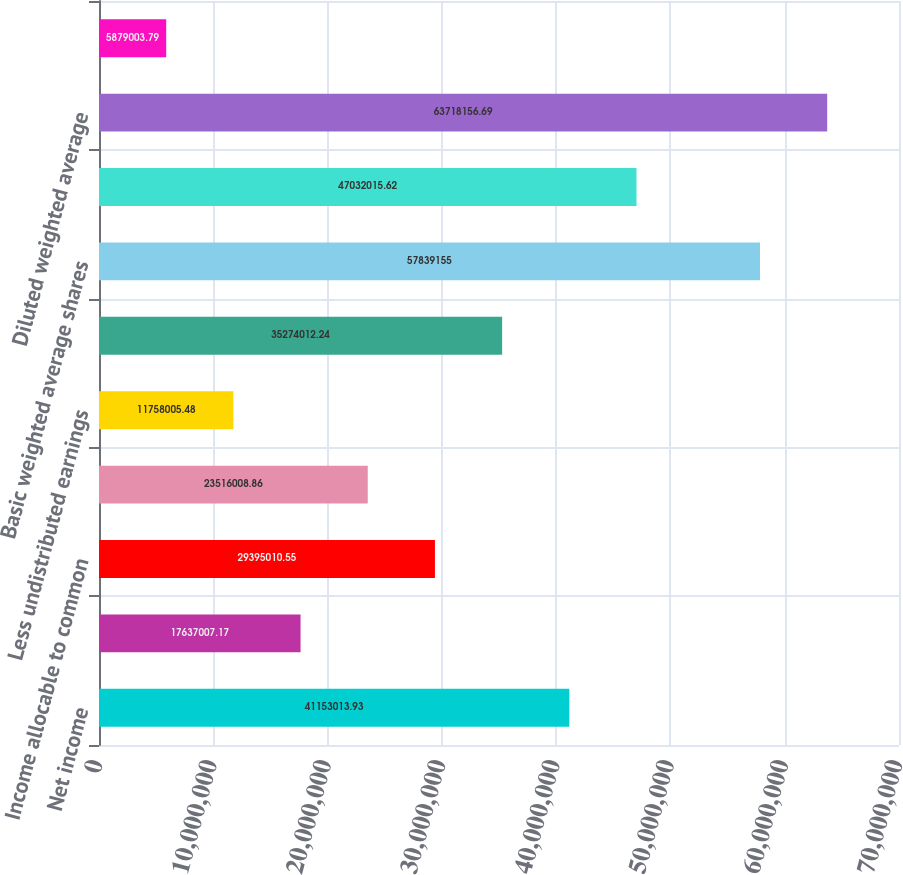<chart> <loc_0><loc_0><loc_500><loc_500><bar_chart><fcel>Net income<fcel>Less income allocable to<fcel>Income allocable to common<fcel>Add back undistributed<fcel>Less undistributed earnings<fcel>Numerator for diluted earnings<fcel>Basic weighted average shares<fcel>Dilutive effect of unvested<fcel>Diluted weighted average<fcel>Basic<nl><fcel>4.1153e+07<fcel>1.7637e+07<fcel>2.9395e+07<fcel>2.3516e+07<fcel>1.1758e+07<fcel>3.5274e+07<fcel>5.78392e+07<fcel>4.7032e+07<fcel>6.37182e+07<fcel>5.879e+06<nl></chart> 